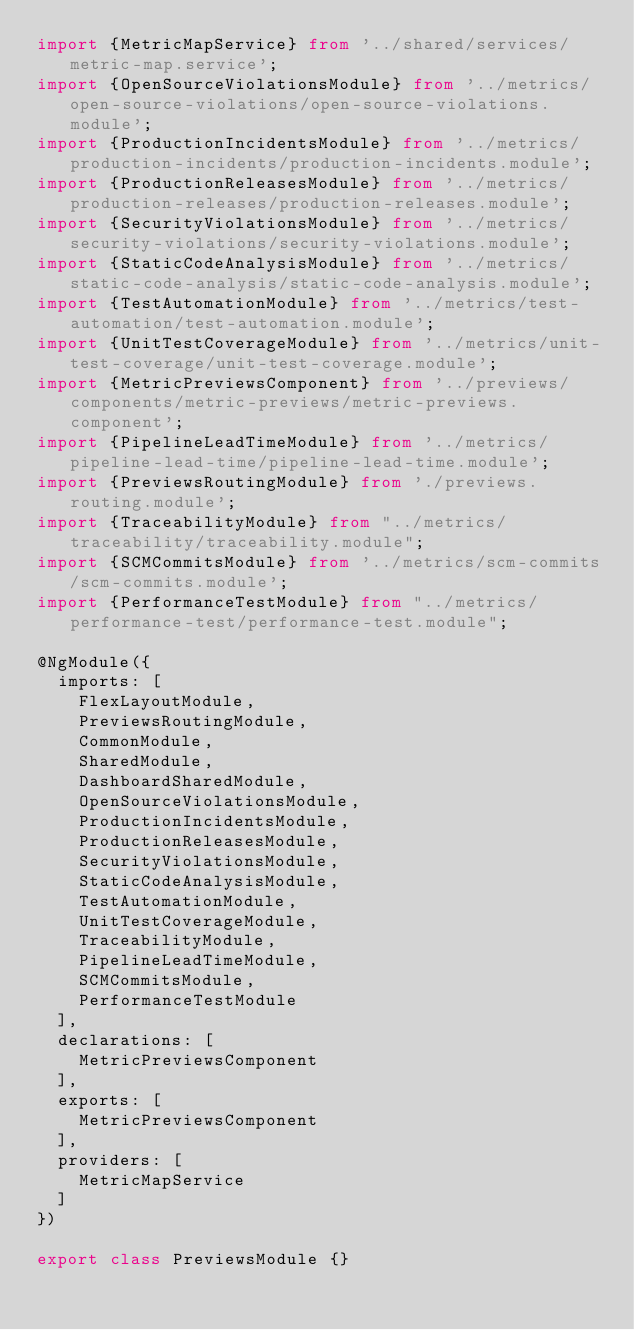<code> <loc_0><loc_0><loc_500><loc_500><_TypeScript_>import {MetricMapService} from '../shared/services/metric-map.service';
import {OpenSourceViolationsModule} from '../metrics/open-source-violations/open-source-violations.module';
import {ProductionIncidentsModule} from '../metrics/production-incidents/production-incidents.module';
import {ProductionReleasesModule} from '../metrics/production-releases/production-releases.module';
import {SecurityViolationsModule} from '../metrics/security-violations/security-violations.module';
import {StaticCodeAnalysisModule} from '../metrics/static-code-analysis/static-code-analysis.module';
import {TestAutomationModule} from '../metrics/test-automation/test-automation.module';
import {UnitTestCoverageModule} from '../metrics/unit-test-coverage/unit-test-coverage.module';
import {MetricPreviewsComponent} from '../previews/components/metric-previews/metric-previews.component';
import {PipelineLeadTimeModule} from '../metrics/pipeline-lead-time/pipeline-lead-time.module';
import {PreviewsRoutingModule} from './previews.routing.module';
import {TraceabilityModule} from "../metrics/traceability/traceability.module";
import {SCMCommitsModule} from '../metrics/scm-commits/scm-commits.module';
import {PerformanceTestModule} from "../metrics/performance-test/performance-test.module";

@NgModule({
  imports: [
    FlexLayoutModule,
    PreviewsRoutingModule,
    CommonModule,
    SharedModule,
    DashboardSharedModule,
    OpenSourceViolationsModule,
    ProductionIncidentsModule,
    ProductionReleasesModule,
    SecurityViolationsModule,
    StaticCodeAnalysisModule,
    TestAutomationModule,
    UnitTestCoverageModule,
    TraceabilityModule,
    PipelineLeadTimeModule,
    SCMCommitsModule,
    PerformanceTestModule
  ],
  declarations: [
    MetricPreviewsComponent
  ],
  exports: [
    MetricPreviewsComponent
  ],
  providers: [
    MetricMapService
  ]
})

export class PreviewsModule {}
</code> 